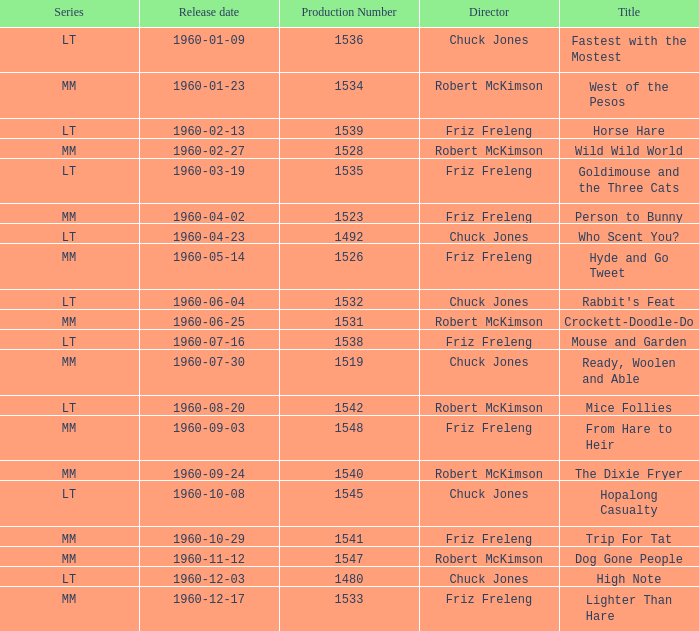What is the Series number of the episode with a production number of 1547? MM. 